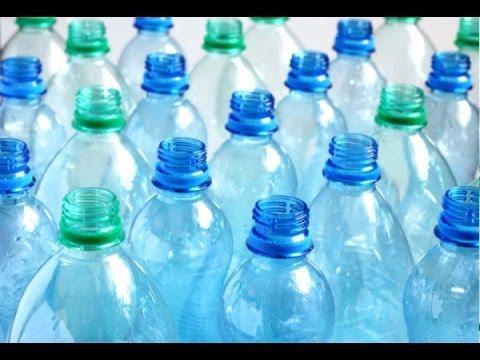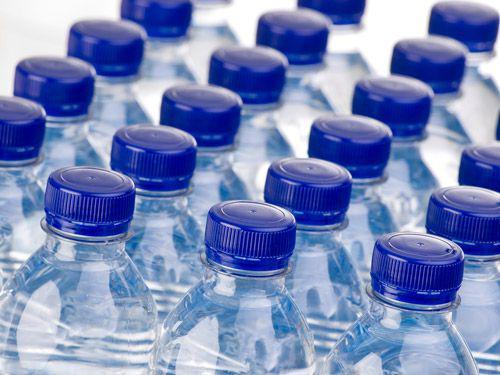The first image is the image on the left, the second image is the image on the right. For the images displayed, is the sentence "All bottles of water have blue plastic caps." factually correct? Answer yes or no. No. 